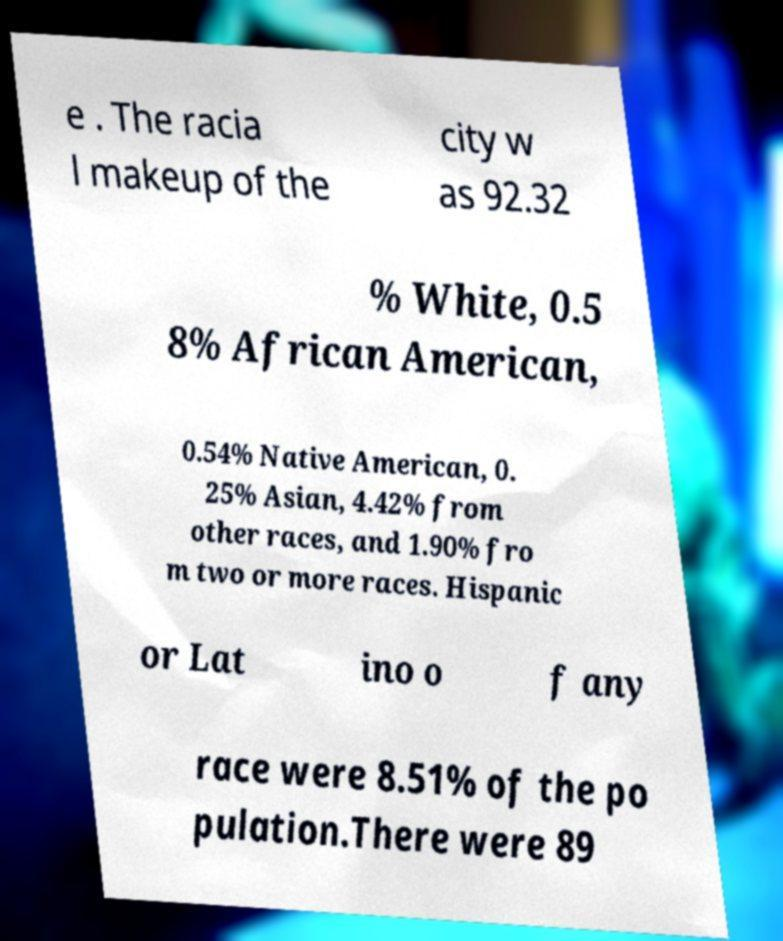Can you read and provide the text displayed in the image?This photo seems to have some interesting text. Can you extract and type it out for me? e . The racia l makeup of the city w as 92.32 % White, 0.5 8% African American, 0.54% Native American, 0. 25% Asian, 4.42% from other races, and 1.90% fro m two or more races. Hispanic or Lat ino o f any race were 8.51% of the po pulation.There were 89 